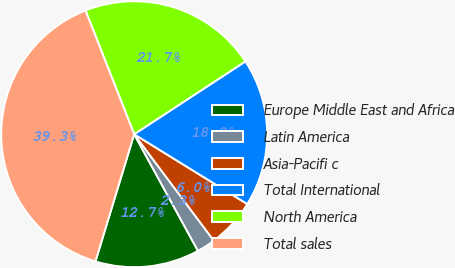Convert chart. <chart><loc_0><loc_0><loc_500><loc_500><pie_chart><fcel>Europe Middle East and Africa<fcel>Latin America<fcel>Asia-Pacifi c<fcel>Total International<fcel>North America<fcel>Total sales<nl><fcel>12.67%<fcel>2.26%<fcel>5.97%<fcel>18.03%<fcel>21.74%<fcel>39.33%<nl></chart> 